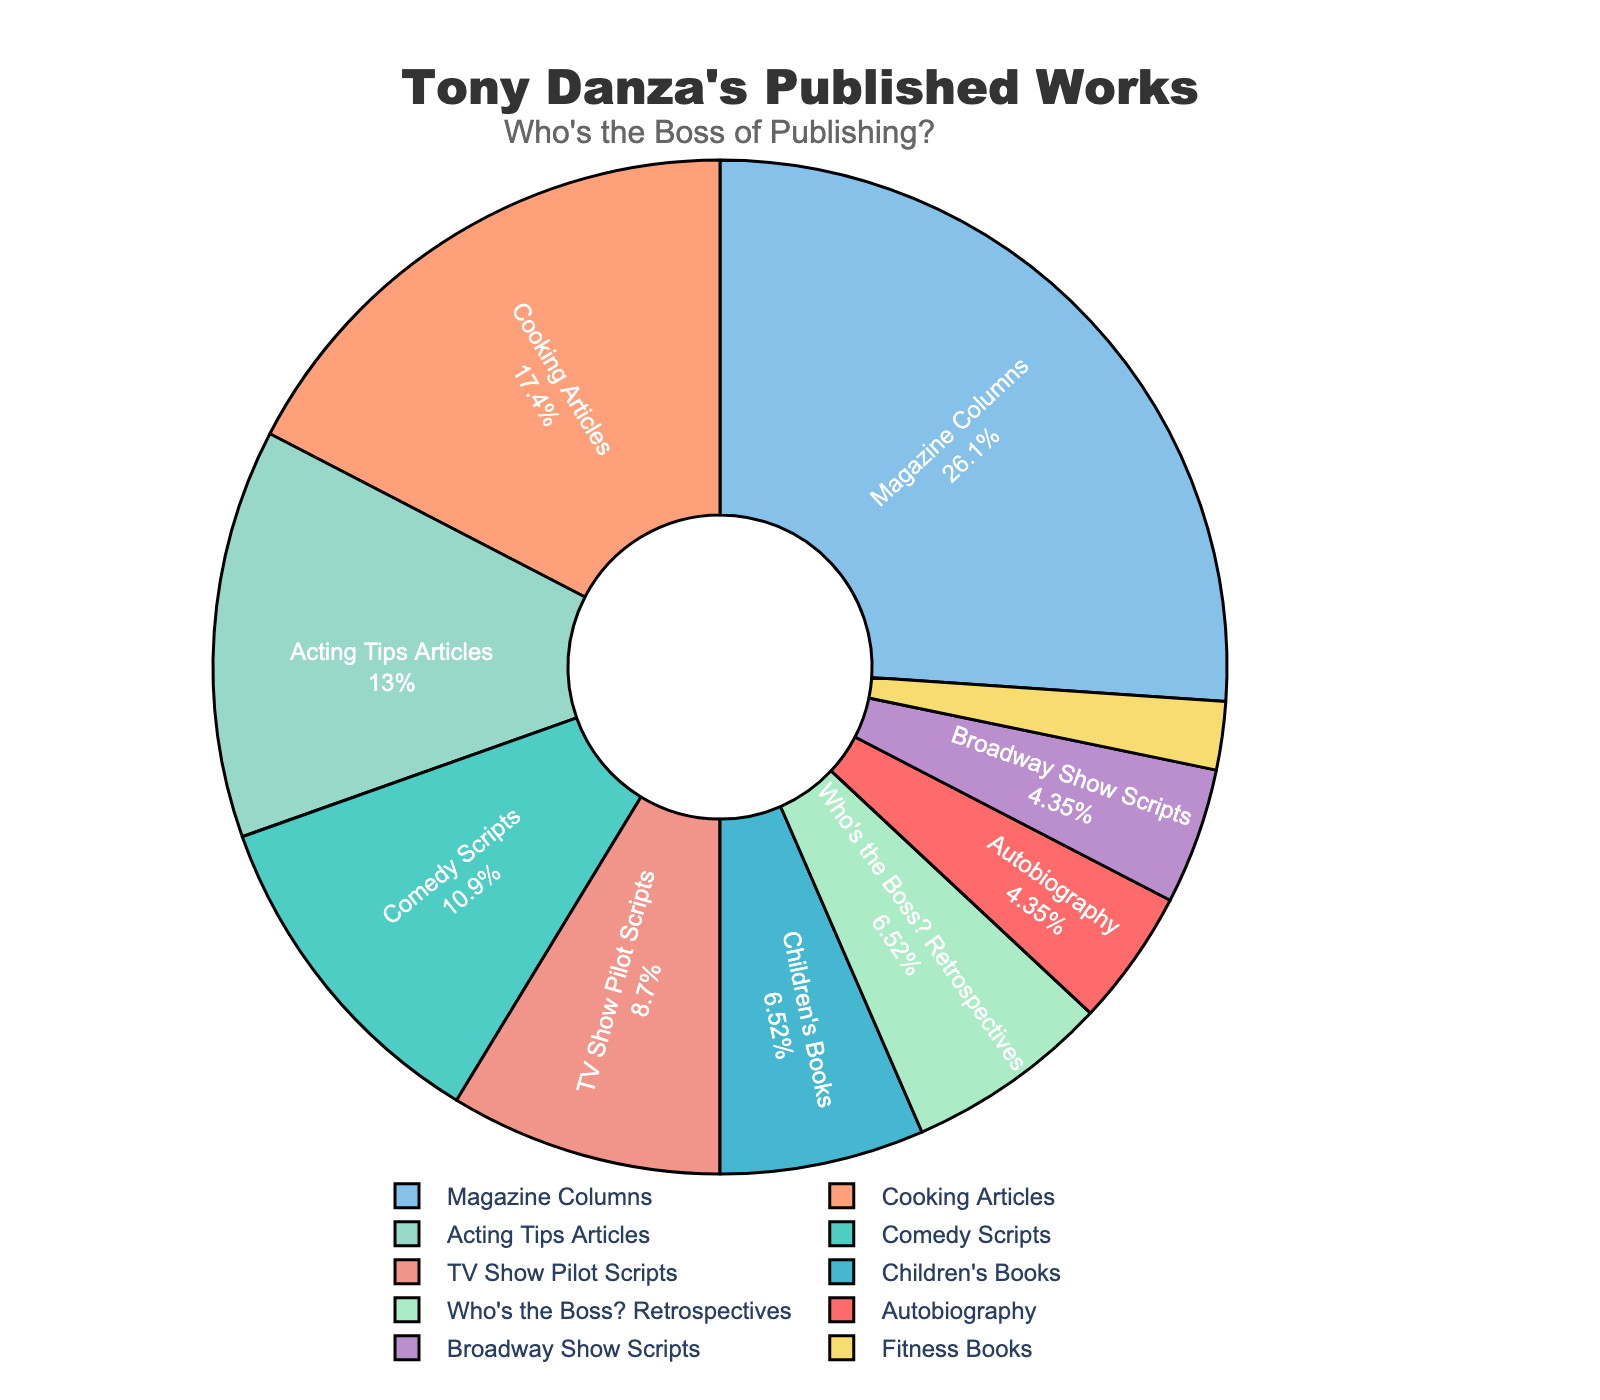what percentage of Tony Danza's works are Magazine Columns? Calculate the percentage by dividing the count of Magazine Columns (12) by the total count of all categories and multiplying by 100. Total count is 46. Thus, (12 / 46) * 100 ≈ 26.09%.
Answer: Approximately 26.09% How does the number of Comedy Scripts compare to TV Show Pilot Scripts and Broadway Show Scripts combined? Sum the counts of TV Show Pilot Scripts (4) and Broadway Show Scripts (2) which gives 6. Compare 5 (Comedy Scripts) with 6 (combined scripts). 5 is less than 6.
Answer: Less Which type of work does Tony Danza have the fewest of? Identify the category with the smallest count. Fitness Books has the lowest count of 1.
Answer: Fitness Books What is the combined percentage of Cooking Articles and Acting Tips Articles? Calculate the percentage for each category and then add them. Cooking Articles: (8 / 46) * 100 ≈ 17.39%, Acting Tips Articles: (6 / 46) * 100 ≈ 13.04%, combined ≈ 30.43%.
Answer: Approximately 30.43% What color is used to represent "Who's the Boss?" Retrospectives in the pie chart? Observe the section labeled "Who's the Boss?" Retrospectives and note the color used. Please check the specific color in the figure for accurate information.
Answer: Need visual confirmation Which category has more works, Children's Books or Acting Tips Articles? Compare the counts: Children's Books (3) and Acting Tips Articles (6). 3 is less than 6.
Answer: Acting Tips Articles How many more Magazine Columns are there compared to Broadway Show Scripts? Subtract the count of Broadway Show Scripts (2) from Magazine Columns (12). 12 - 2 = 10.
Answer: 10 more What is the largest segment in the pie chart? Identify the segment with the largest value. Magazine Columns has the highest count of 12.
Answer: Magazine Columns What is the median value of the counts? List all counts in ascending order: [1, 2, 2, 3, 3, 4, 5, 6, 8, 12], the median value is the average of the 5th and 6th values: (3 + 4) / 2 = 3.5.
Answer: 3.5 What are the combined counts of scripts (Comedy Scripts, Broadway Show Scripts, and TV Show Pilot Scripts)? Add the counts of Comedy Scripts (5), Broadway Show Scripts (2), and TV Show Pilot Scripts (4). 5 + 2 + 4 = 11.
Answer: 11 